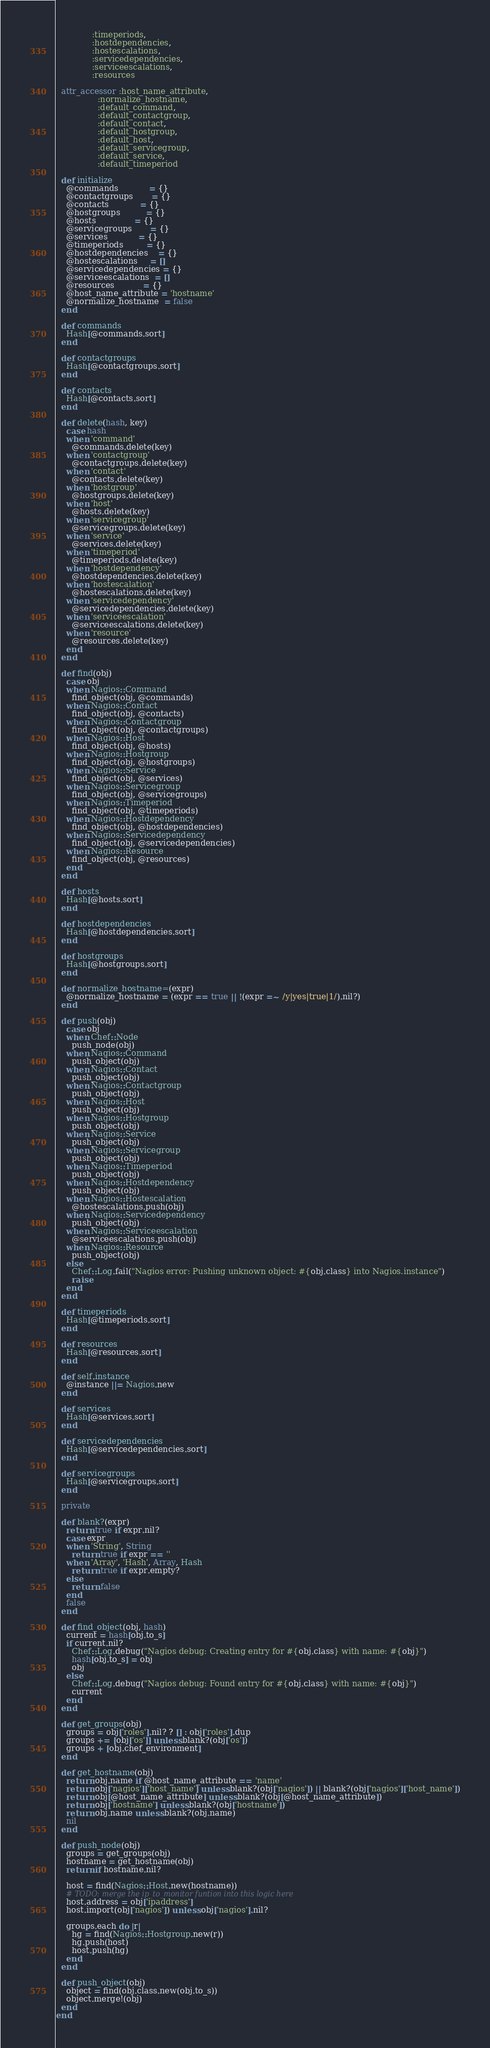<code> <loc_0><loc_0><loc_500><loc_500><_Ruby_>              :timeperiods,
              :hostdependencies,
              :hostescalations,
              :servicedependencies,
              :serviceescalations,
              :resources

  attr_accessor :host_name_attribute,
                :normalize_hostname,
                :default_command,
                :default_contactgroup,
                :default_contact,
                :default_hostgroup,
                :default_host,
                :default_servicegroup,
                :default_service,
                :default_timeperiod

  def initialize
    @commands            = {}
    @contactgroups       = {}
    @contacts            = {}
    @hostgroups          = {}
    @hosts               = {}
    @servicegroups       = {}
    @services            = {}
    @timeperiods         = {}
    @hostdependencies    = {}
    @hostescalations     = []
    @servicedependencies = {}
    @serviceescalations  = []
    @resources           = {}
    @host_name_attribute = 'hostname'
    @normalize_hostname  = false
  end

  def commands
    Hash[@commands.sort]
  end

  def contactgroups
    Hash[@contactgroups.sort]
  end

  def contacts
    Hash[@contacts.sort]
  end

  def delete(hash, key)
    case hash
    when 'command'
      @commands.delete(key)
    when 'contactgroup'
      @contactgroups.delete(key)
    when 'contact'
      @contacts.delete(key)
    when 'hostgroup'
      @hostgroups.delete(key)
    when 'host'
      @hosts.delete(key)
    when 'servicegroup'
      @servicegroups.delete(key)
    when 'service'
      @services.delete(key)
    when 'timeperiod'
      @timeperiods.delete(key)
    when 'hostdependency'
      @hostdependencies.delete(key)
    when 'hostescalation'
      @hostescalations.delete(key)
    when 'servicedependency'
      @servicedependencies.delete(key)
    when 'serviceescalation'
      @serviceescalations.delete(key)
    when 'resource'
      @resources.delete(key)
    end
  end

  def find(obj)
    case obj
    when Nagios::Command
      find_object(obj, @commands)
    when Nagios::Contact
      find_object(obj, @contacts)
    when Nagios::Contactgroup
      find_object(obj, @contactgroups)
    when Nagios::Host
      find_object(obj, @hosts)
    when Nagios::Hostgroup
      find_object(obj, @hostgroups)
    when Nagios::Service
      find_object(obj, @services)
    when Nagios::Servicegroup
      find_object(obj, @servicegroups)
    when Nagios::Timeperiod
      find_object(obj, @timeperiods)
    when Nagios::Hostdependency
      find_object(obj, @hostdependencies)
    when Nagios::Servicedependency
      find_object(obj, @servicedependencies)
    when Nagios::Resource
      find_object(obj, @resources)
    end
  end

  def hosts
    Hash[@hosts.sort]
  end

  def hostdependencies
    Hash[@hostdependencies.sort]
  end

  def hostgroups
    Hash[@hostgroups.sort]
  end

  def normalize_hostname=(expr)
    @normalize_hostname = (expr == true || !(expr =~ /y|yes|true|1/).nil?)
  end

  def push(obj)
    case obj
    when Chef::Node
      push_node(obj)
    when Nagios::Command
      push_object(obj)
    when Nagios::Contact
      push_object(obj)
    when Nagios::Contactgroup
      push_object(obj)
    when Nagios::Host
      push_object(obj)
    when Nagios::Hostgroup
      push_object(obj)
    when Nagios::Service
      push_object(obj)
    when Nagios::Servicegroup
      push_object(obj)
    when Nagios::Timeperiod
      push_object(obj)
    when Nagios::Hostdependency
      push_object(obj)
    when Nagios::Hostescalation
      @hostescalations.push(obj)
    when Nagios::Servicedependency
      push_object(obj)
    when Nagios::Serviceescalation
      @serviceescalations.push(obj)
    when Nagios::Resource
      push_object(obj)
    else
      Chef::Log.fail("Nagios error: Pushing unknown object: #{obj.class} into Nagios.instance")
      raise
    end
  end

  def timeperiods
    Hash[@timeperiods.sort]
  end

  def resources
    Hash[@resources.sort]
  end

  def self.instance
    @instance ||= Nagios.new
  end

  def services
    Hash[@services.sort]
  end

  def servicedependencies
    Hash[@servicedependencies.sort]
  end

  def servicegroups
    Hash[@servicegroups.sort]
  end

  private

  def blank?(expr)
    return true if expr.nil?
    case expr
    when 'String', String
      return true if expr == ''
    when 'Array', 'Hash', Array, Hash
      return true if expr.empty?
    else
      return false
    end
    false
  end

  def find_object(obj, hash)
    current = hash[obj.to_s]
    if current.nil?
      Chef::Log.debug("Nagios debug: Creating entry for #{obj.class} with name: #{obj}")
      hash[obj.to_s] = obj
      obj
    else
      Chef::Log.debug("Nagios debug: Found entry for #{obj.class} with name: #{obj}")
      current
    end
  end

  def get_groups(obj)
    groups = obj['roles'].nil? ? [] : obj['roles'].dup
    groups += [obj['os']] unless blank?(obj['os'])
    groups + [obj.chef_environment]
  end

  def get_hostname(obj)
    return obj.name if @host_name_attribute == 'name'
    return obj['nagios']['host_name'] unless blank?(obj['nagios']) || blank?(obj['nagios']['host_name'])
    return obj[@host_name_attribute] unless blank?(obj[@host_name_attribute])
    return obj['hostname'] unless blank?(obj['hostname'])
    return obj.name unless blank?(obj.name)
    nil
  end

  def push_node(obj)
    groups = get_groups(obj)
    hostname = get_hostname(obj)
    return if hostname.nil?

    host = find(Nagios::Host.new(hostname))
    # TODO: merge the ip_to_monitor funtion into this logic here
    host.address = obj['ipaddress']
    host.import(obj['nagios']) unless obj['nagios'].nil?

    groups.each do |r|
      hg = find(Nagios::Hostgroup.new(r))
      hg.push(host)
      host.push(hg)
    end
  end

  def push_object(obj)
    object = find(obj.class.new(obj.to_s))
    object.merge!(obj)
  end
end
</code> 